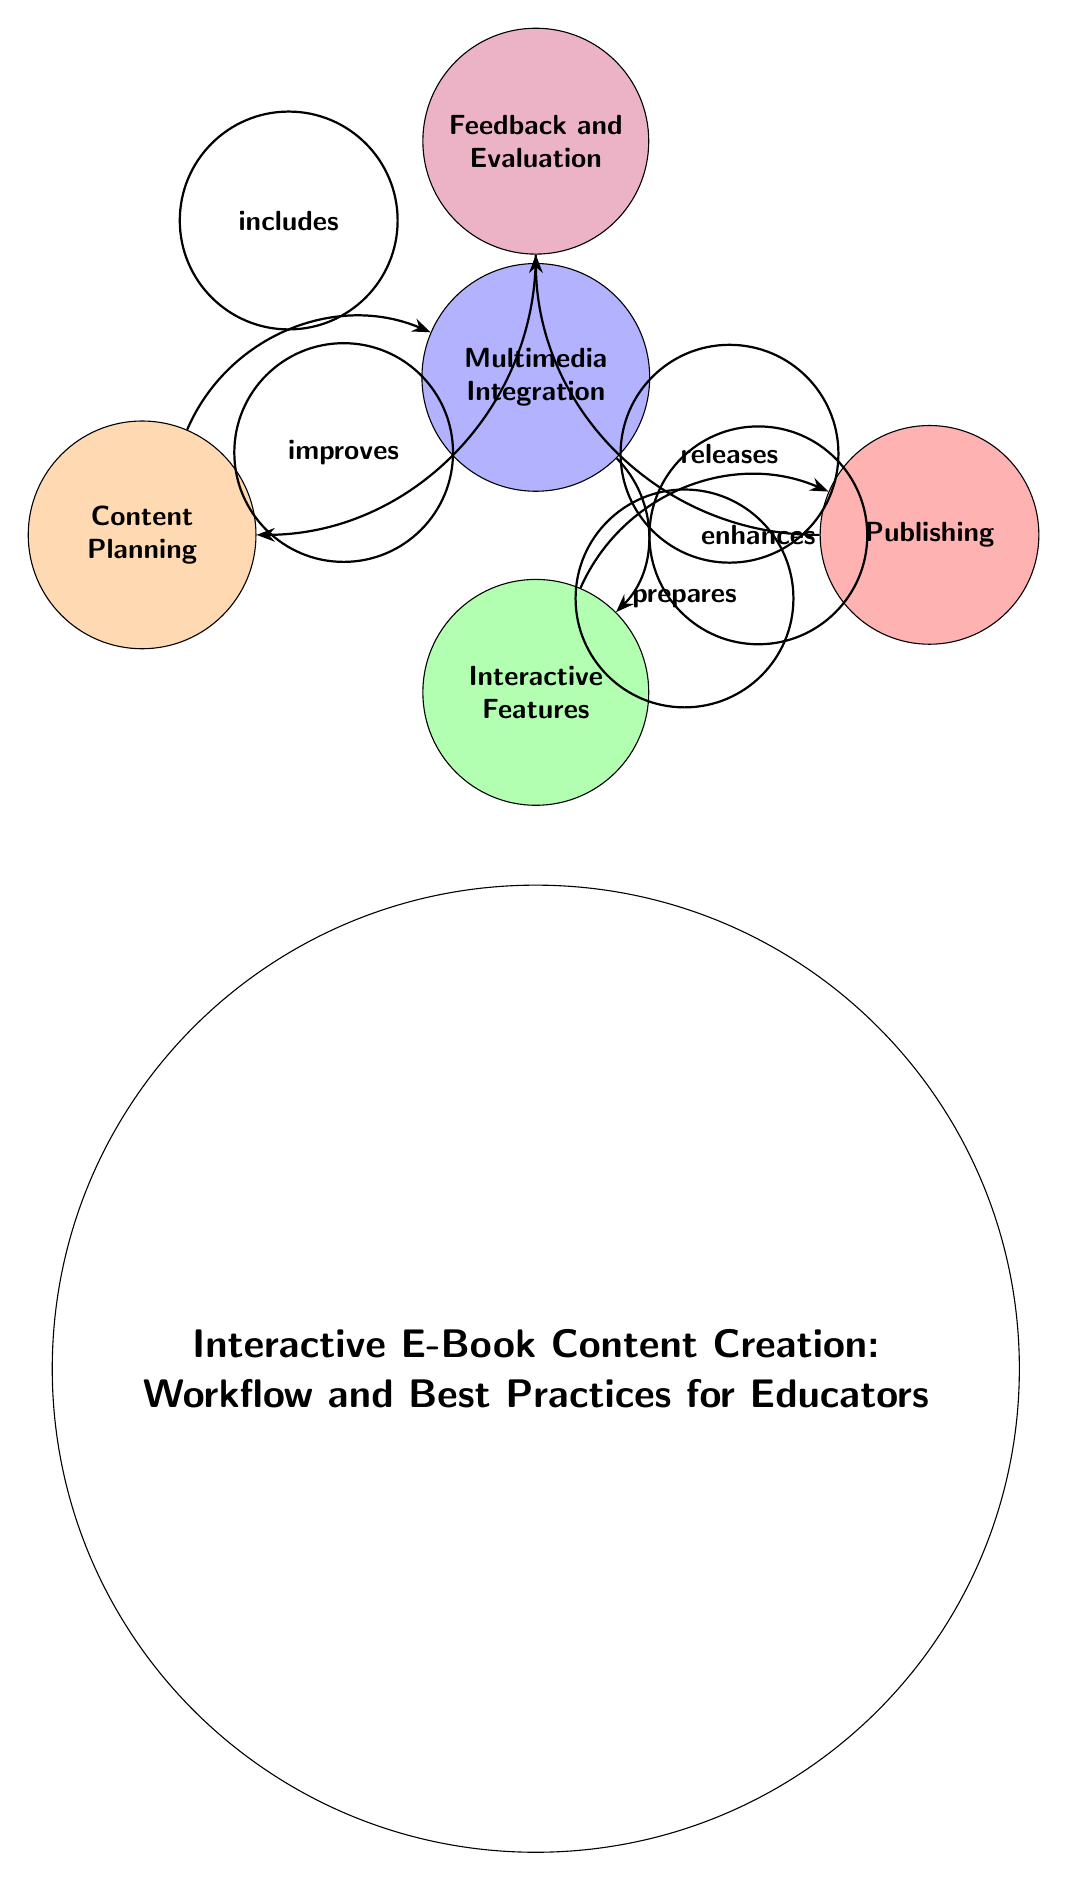What is the first step in the workflow? The diagram indicates that the first step in the workflow is "Content Planning," which is represented by the first node on the left.
Answer: Content Planning How many nodes are present in the diagram? Counting the visible circles in the diagram, there are five distinct nodes representing different stages of the workflow.
Answer: 5 What color represents "Publishing"? Looking at the diagram, "Publishing" is represented by a red node, which is visually distinct from the other colors used.
Answer: Red What is the relationship between "Multimedia Integration" and "Interactive Features"? The arrow from "Multimedia Integration" to "Interactive Features" indicates that "Multimedia Integration" enhances "Interactive Features," establishing a direct relationship between these two nodes.
Answer: Enhances Which node receives feedback from "Publishing"? In the diagram, the arrow points from "Publishing" to "Feedback and Evaluation," indicating that this node receives feedback directly from the publishing process.
Answer: Feedback and Evaluation What is one of the purposes of the "Feedback and Evaluation" phase? The diagram suggests that "Feedback and Evaluation" improves the initial step of "Content Planning," indicating that it plays a critical role in refining educational content.
Answer: Improves What follows "Interactive Features" in the workflow? The diagram shows the flow of the process where "Interactive Features" prepares for the next step, which is "Publishing."
Answer: Publishing Which step is directly before "Multimedia Integration"? The workflow diagram states that "Content Planning" directly leads into "Multimedia Integration" as the first step before integrating multimedia elements.
Answer: Content Planning 